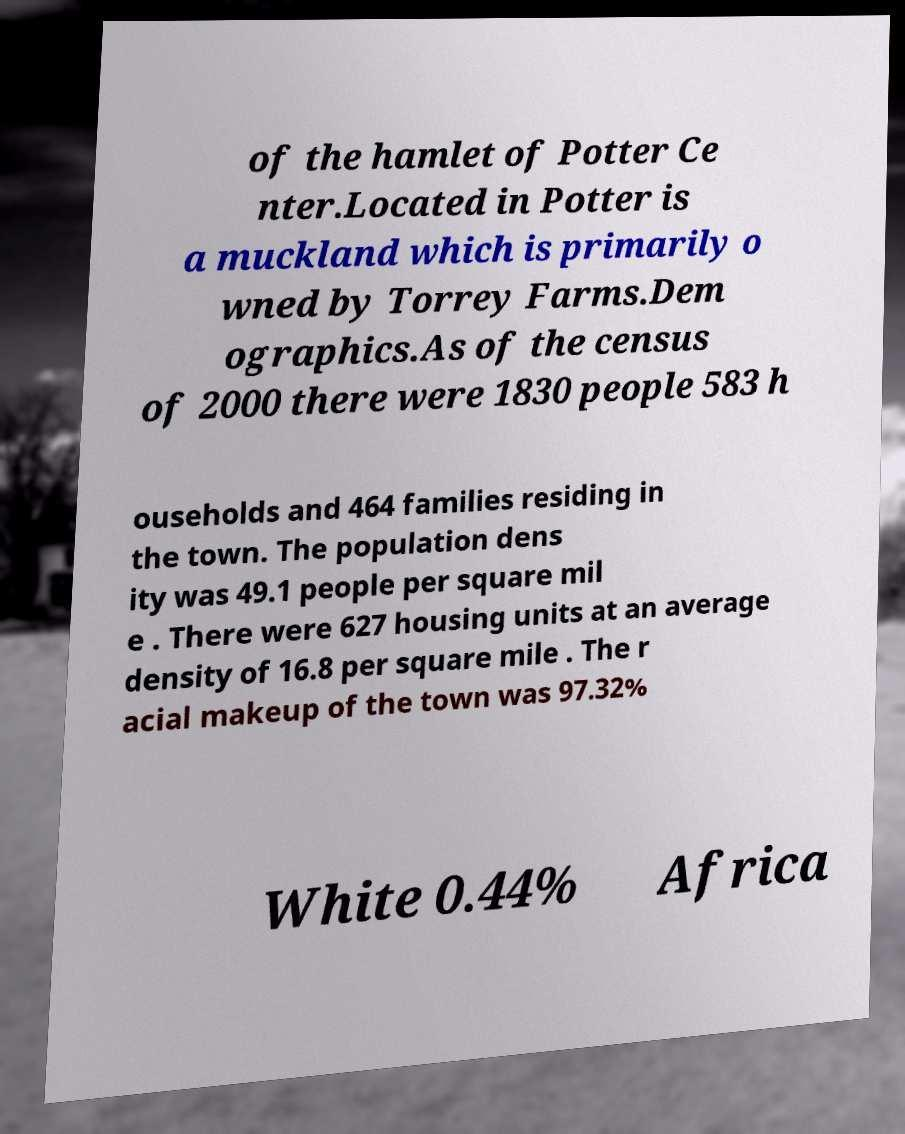I need the written content from this picture converted into text. Can you do that? of the hamlet of Potter Ce nter.Located in Potter is a muckland which is primarily o wned by Torrey Farms.Dem ographics.As of the census of 2000 there were 1830 people 583 h ouseholds and 464 families residing in the town. The population dens ity was 49.1 people per square mil e . There were 627 housing units at an average density of 16.8 per square mile . The r acial makeup of the town was 97.32% White 0.44% Africa 